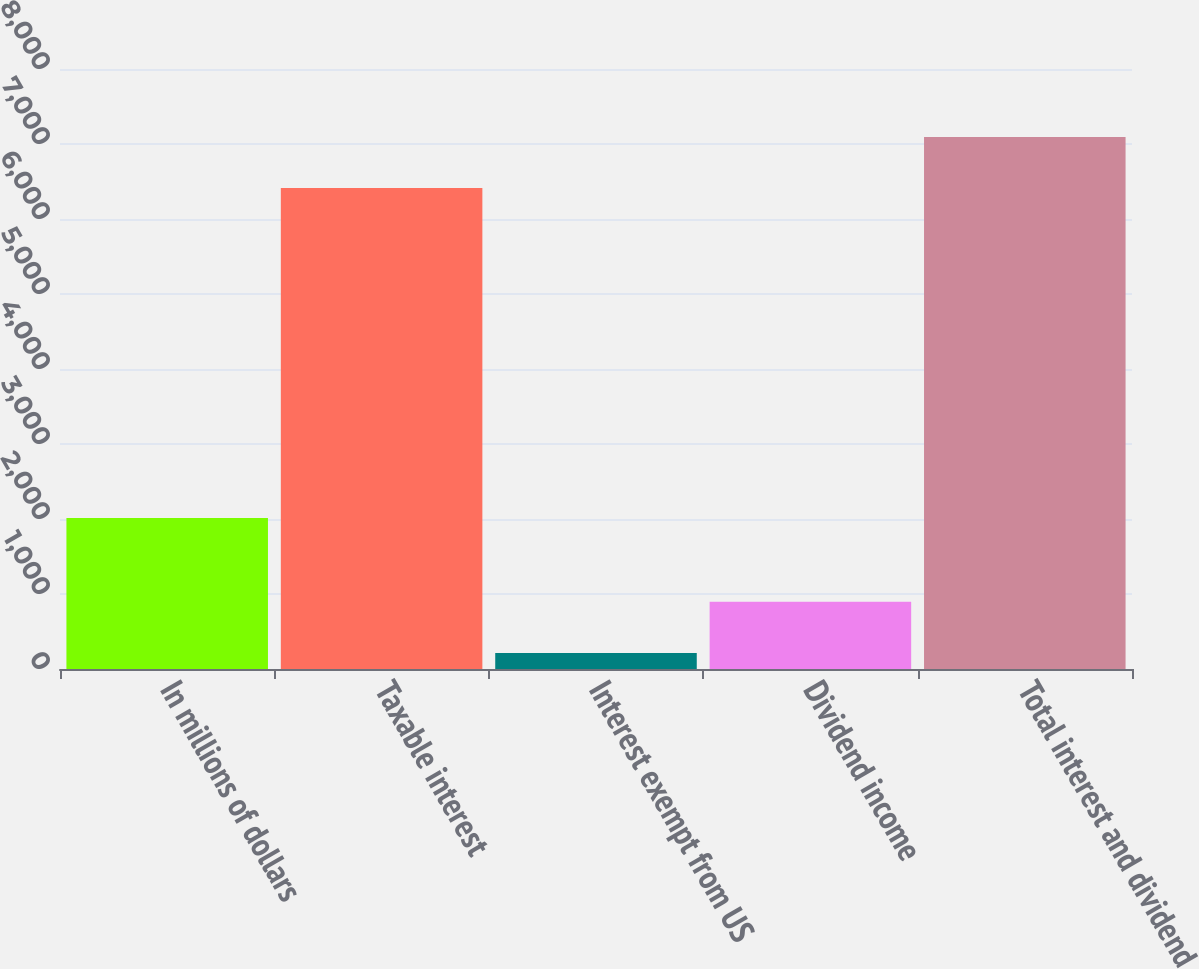Convert chart to OTSL. <chart><loc_0><loc_0><loc_500><loc_500><bar_chart><fcel>In millions of dollars<fcel>Taxable interest<fcel>Interest exempt from US<fcel>Dividend income<fcel>Total interest and dividend<nl><fcel>2015<fcel>6414<fcel>215<fcel>895.2<fcel>7094.2<nl></chart> 